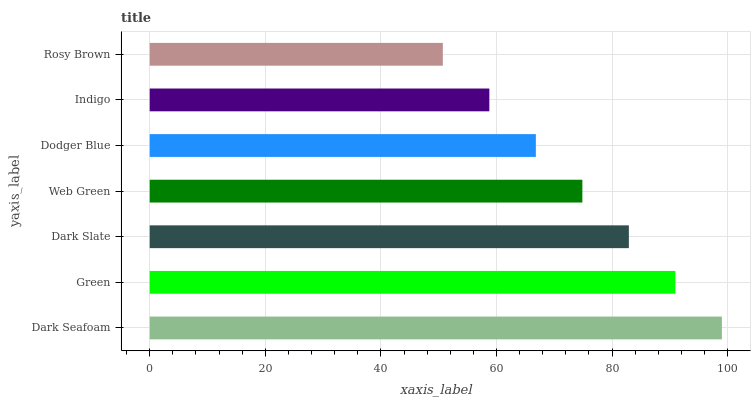Is Rosy Brown the minimum?
Answer yes or no. Yes. Is Dark Seafoam the maximum?
Answer yes or no. Yes. Is Green the minimum?
Answer yes or no. No. Is Green the maximum?
Answer yes or no. No. Is Dark Seafoam greater than Green?
Answer yes or no. Yes. Is Green less than Dark Seafoam?
Answer yes or no. Yes. Is Green greater than Dark Seafoam?
Answer yes or no. No. Is Dark Seafoam less than Green?
Answer yes or no. No. Is Web Green the high median?
Answer yes or no. Yes. Is Web Green the low median?
Answer yes or no. Yes. Is Dodger Blue the high median?
Answer yes or no. No. Is Rosy Brown the low median?
Answer yes or no. No. 